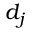Convert formula to latex. <formula><loc_0><loc_0><loc_500><loc_500>d _ { j }</formula> 